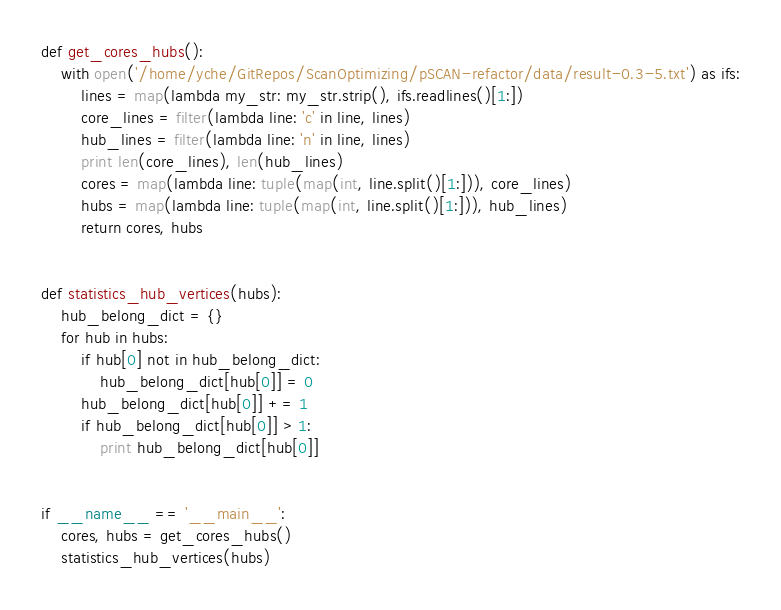<code> <loc_0><loc_0><loc_500><loc_500><_Python_>def get_cores_hubs():
    with open('/home/yche/GitRepos/ScanOptimizing/pSCAN-refactor/data/result-0.3-5.txt') as ifs:
        lines = map(lambda my_str: my_str.strip(), ifs.readlines()[1:])
        core_lines = filter(lambda line: 'c' in line, lines)
        hub_lines = filter(lambda line: 'n' in line, lines)
        print len(core_lines), len(hub_lines)
        cores = map(lambda line: tuple(map(int, line.split()[1:])), core_lines)
        hubs = map(lambda line: tuple(map(int, line.split()[1:])), hub_lines)
        return cores, hubs


def statistics_hub_vertices(hubs):
    hub_belong_dict = {}
    for hub in hubs:
        if hub[0] not in hub_belong_dict:
            hub_belong_dict[hub[0]] = 0
        hub_belong_dict[hub[0]] += 1
        if hub_belong_dict[hub[0]] > 1:
            print hub_belong_dict[hub[0]]


if __name__ == '__main__':
    cores, hubs = get_cores_hubs()
    statistics_hub_vertices(hubs)
</code> 